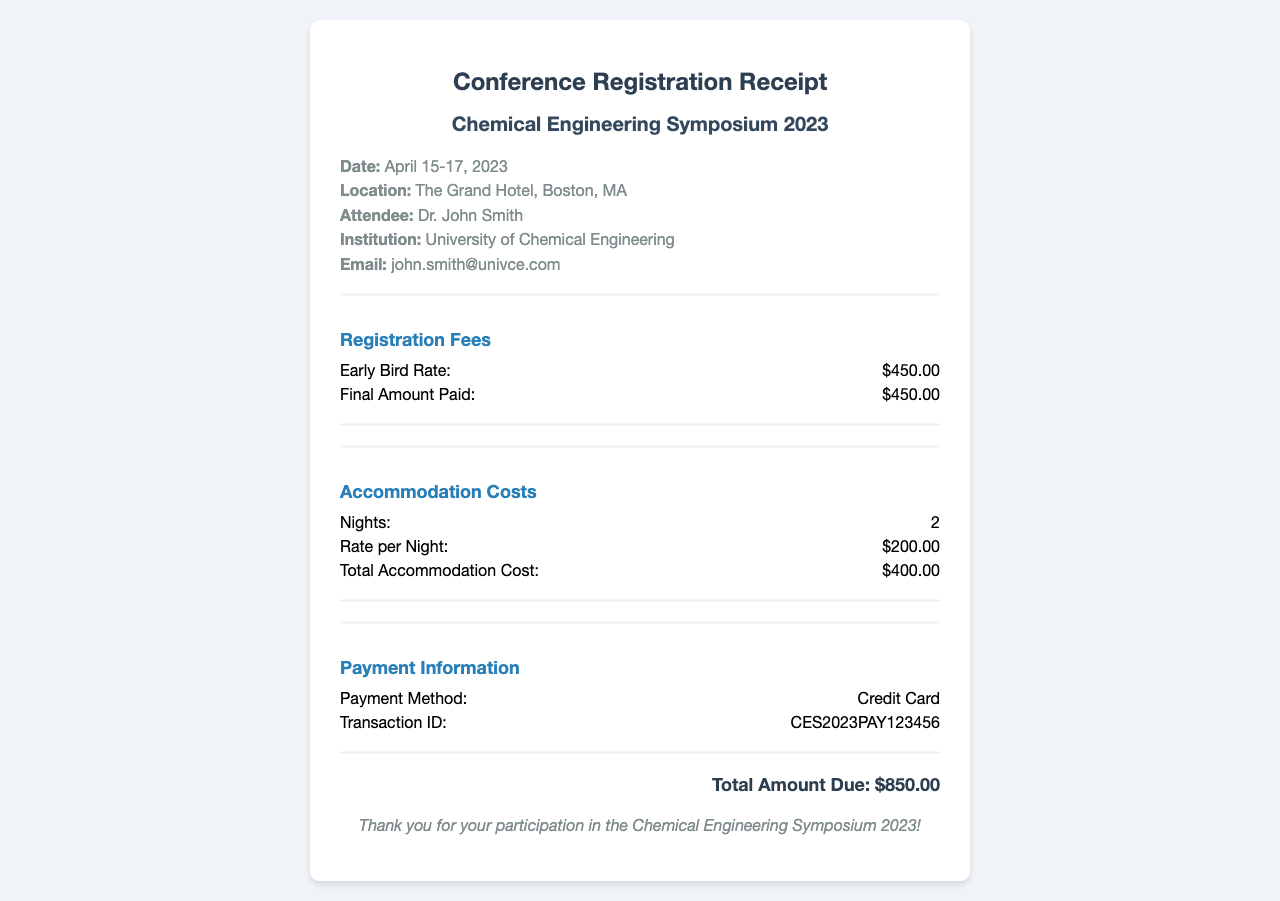What is the date of the conference? The conference is scheduled from April 15 to April 17, 2023.
Answer: April 15-17, 2023 What is the total accommodation cost? The total cost for accommodation for 2 nights at a rate of $200.00 per night is $400.00.
Answer: $400.00 Who is the attendee? The document specifies the name of the attendee, who is the person registering for the conference.
Answer: Dr. John Smith What payment method was used? The document explicitly states the method used to make the payment for registration.
Answer: Credit Card What is the transaction ID? The transaction ID provided in the payment information allows for tracking the payment.
Answer: CES2023PAY123456 How much was paid for the early bird registration rate? The amount paid for early registration can be found in the registration fees section of the receipt.
Answer: $450.00 What is the total amount due? The total amount due is presented at the end as a summary of all costs incurred.
Answer: $850.00 What is the rate per night for accommodation? The receipt lists the accommodation rate, which indicates how much is charged for each night.
Answer: $200.00 How many nights of accommodation were booked? The number of nights that the accommodation was booked for is specified in the document.
Answer: 2 